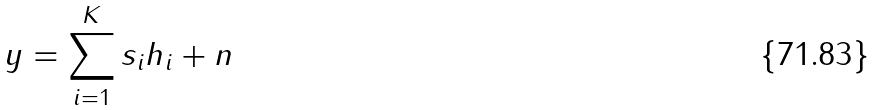Convert formula to latex. <formula><loc_0><loc_0><loc_500><loc_500>y = \sum _ { i = 1 } ^ { K } s _ { i } h _ { i } + n</formula> 